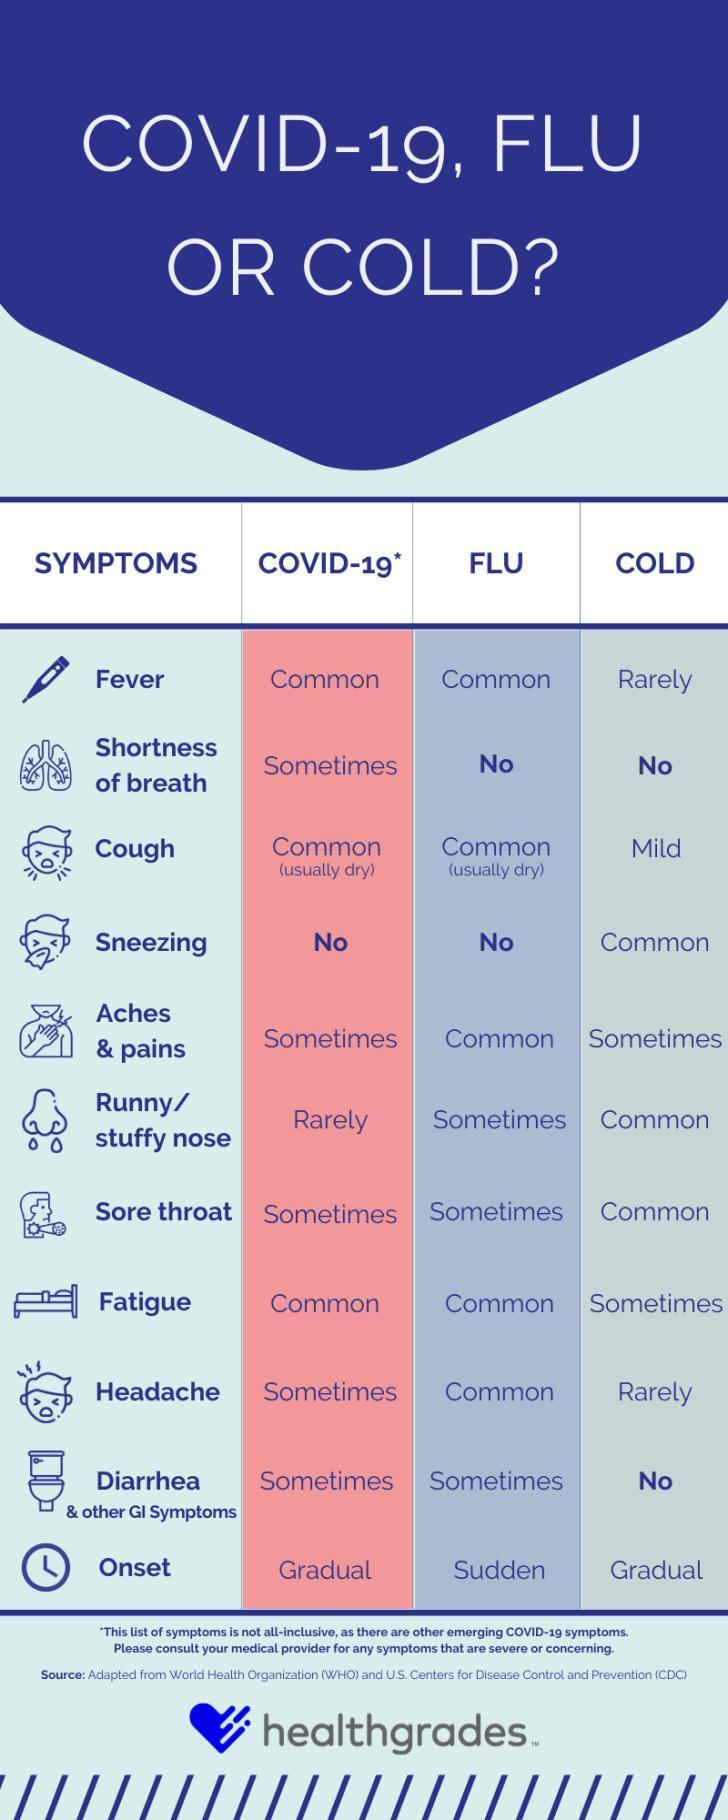Which symptoms are common for both COVID-19 & Flu?
Answer the question with a short phrase. Fever, Cough, Fatigue Which symptom sometimes do occur in COVID-19 but not in Flu & Cold? Shortness of breath Which is a mild symptom of Cold? Cough Which symptom is common only for cold? Sneezing Which symptoms are rare for cold? Fever, Headache 